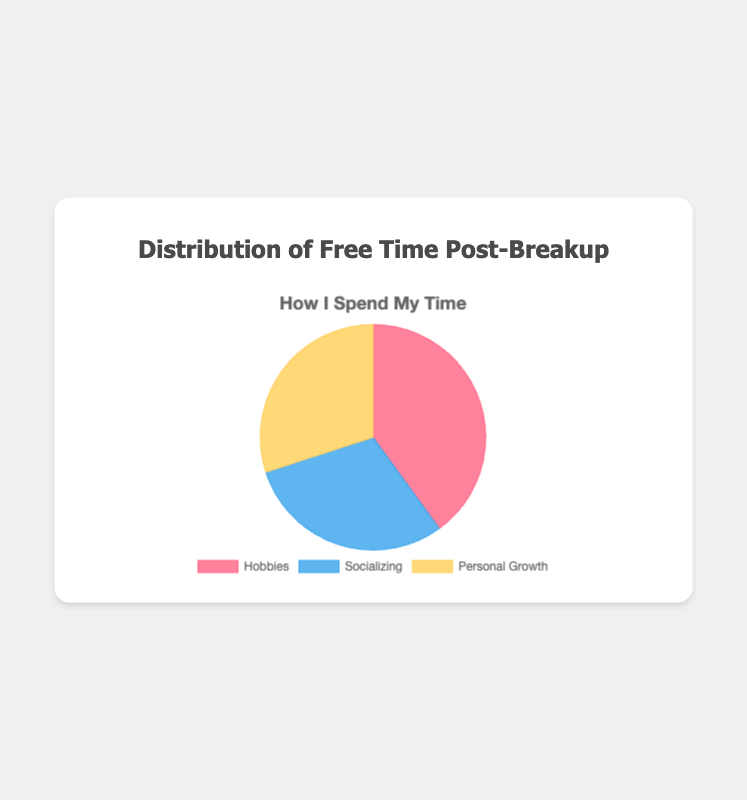Which activity occupies the largest portion of free time post-breakup? The pie chart shows three activities: Hobbies, Socializing, and Personal Growth. The largest portion is represented by the activity with the highest percentage.
Answer: Hobbies How much more time is spent on Hobbies compared to Personal Growth? To find the difference, subtract the percentage of time spent on Personal Growth from the percentage of time spent on Hobbies: 40% - 30% = 10%
Answer: 10% Are Socializing and Personal Growth given equal amounts of free time? Refer to the pie chart and compare the percentages for Socializing and Personal Growth. Both activities have a percentage of 30%.
Answer: Yes What is the combined percentage of time spent on Socializing and Personal Growth? Add the percentages for Socializing and Personal Growth: 30% (Socializing) + 30% (Personal Growth) = 60%
Answer: 60% Is more than half of the free time dedicated to Hobbies? Check if the percentage for Hobbies is greater than 50%. The percentage for Hobbies is 40%, which is less than 50%.
Answer: No If 'Reading' takes up 15% of the time within Hobbies, what percentage of the total free time is spent on Reading? First, calculate the proportion of Reading within Hobbies: 15% of 40%. 15% (0.15) * 40% = 6%. Therefore, Reading takes up this portion of the total free time.
Answer: 6% Between Hobbies and Socializing, which activity has a smaller portion of the free time, and by how much? Compare the percentages for Hobbies (40%) and Socializing (30%). Socializing has a smaller portion. To find the difference: 40% - 30% = 10%.
Answer: Socializing, by 10% What is the combined percentage of time spent on Painting and Gaming from Hobbies? Add the percentages for Painting (5%) and Gaming (10%), both within Hobbies: 5% + 10% = 15%
Answer: 15% Which individual activity within Personal Growth has the smallest representation, and what is its percentage? From the Personal Growth segment, compare the percentages for each activity: Learning New Skills (15%), Meditation (10%), and Therapy Sessions (5%). The smallest percentage is for Therapy Sessions.
Answer: Therapy Sessions, 5% How does the time spent on Hanging Out With Friends compare to the time spent on Family Time within Socializing? Compare the percentages for these activities within the Socializing category: Hanging Out With Friends (20%) and Family Time (5%). Hanging Out With Friends occupies a larger portion.
Answer: Hanging Out With Friends is larger by 15% 